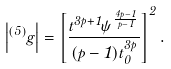<formula> <loc_0><loc_0><loc_500><loc_500>\left | ^ { ( 5 ) } g \right | = \left [ \frac { t ^ { 3 p + 1 } \psi ^ { \frac { 4 p - 1 } { p - 1 } } } { ( p - 1 ) t ^ { 3 p } _ { 0 } } \right ] ^ { 2 } .</formula> 